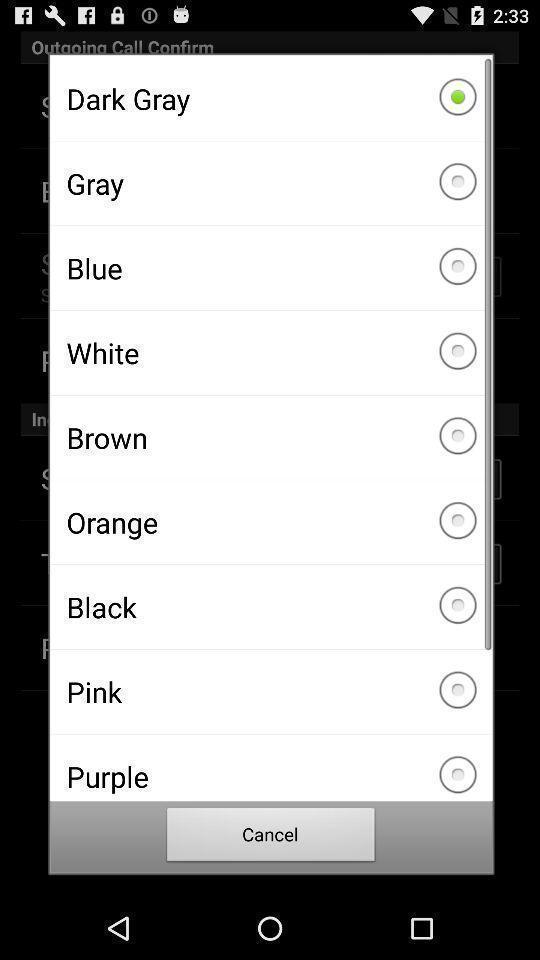Summarize the information in this screenshot. Pop-up showing different colors. 